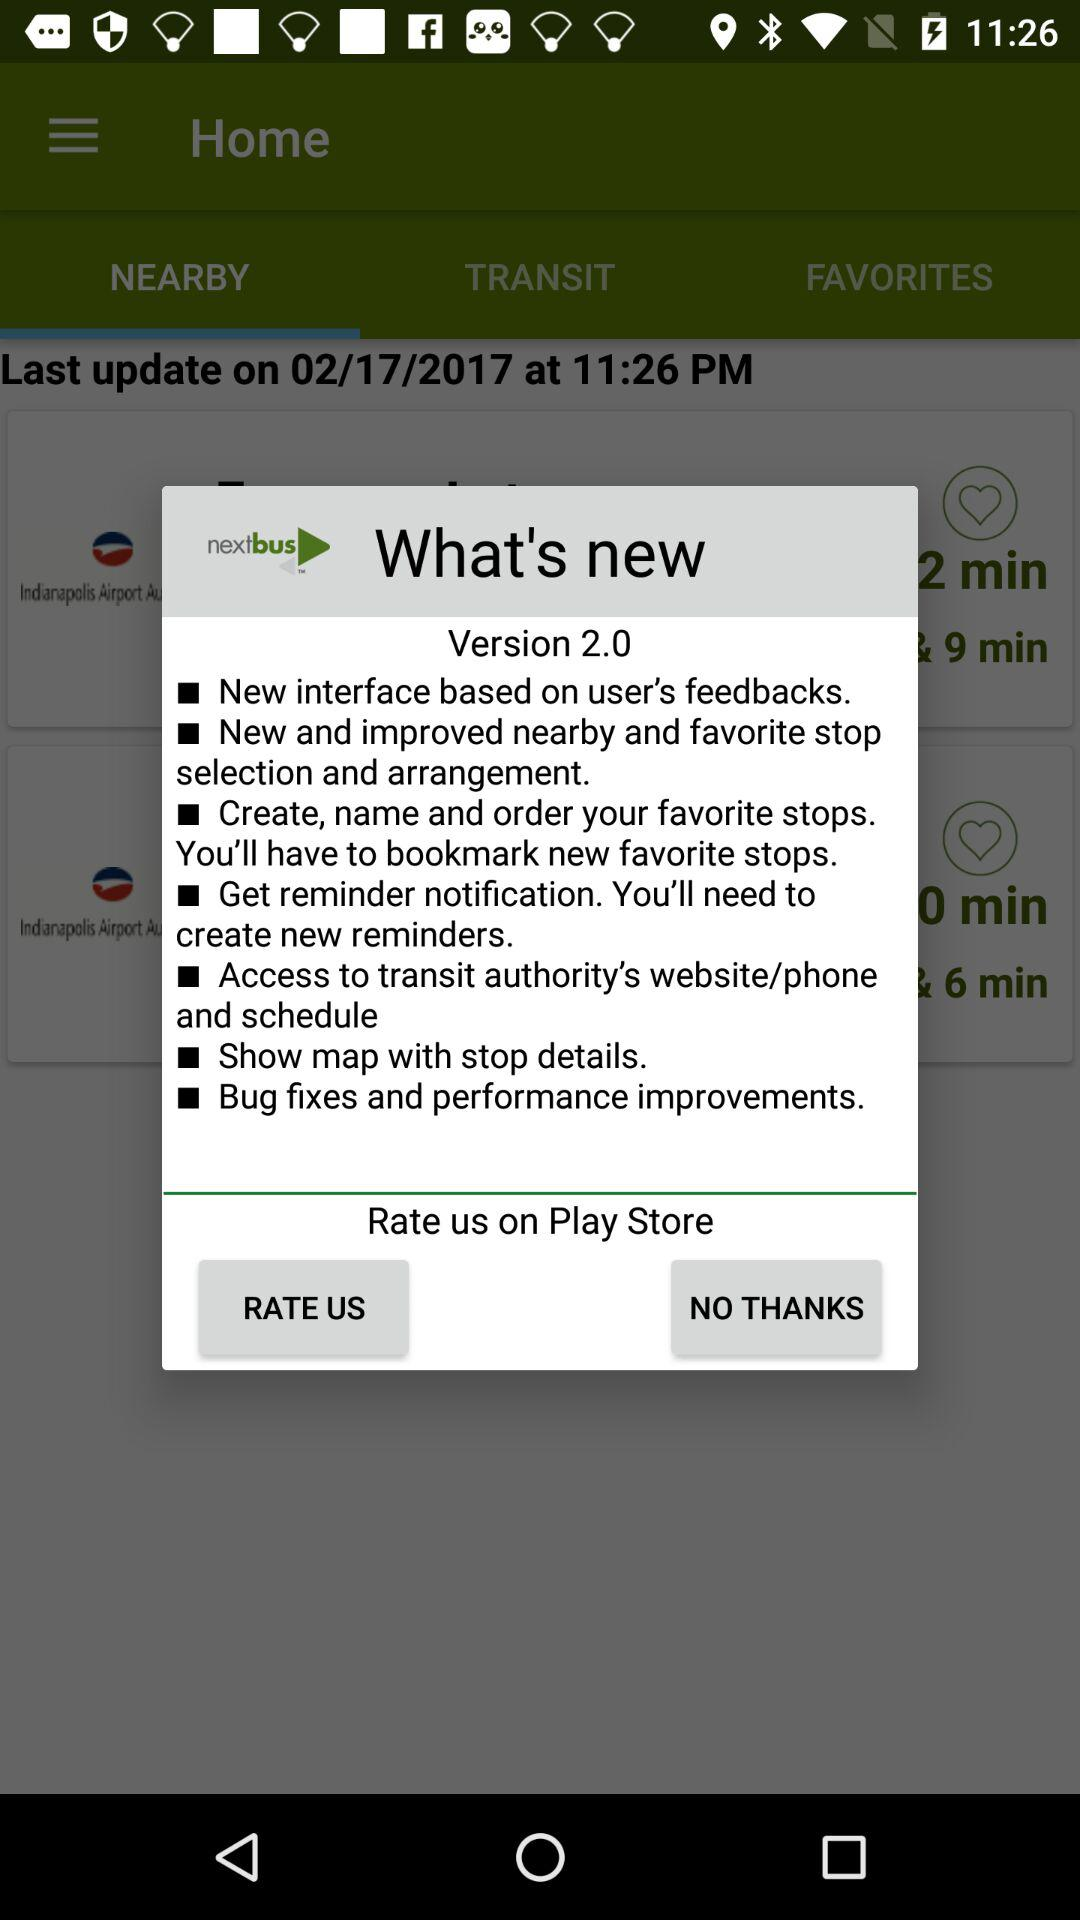What's new in version 2.0?
Answer the question using a single word or phrase. The new updates are "New interface based on user's feedbacks.", "New and improved nearby and favorite stop selection and arrangement.", "Create, name and order your favorite stops.You'll have to bookmark new favorite stops.", "Get reminder notification. You'll need to create new reminders.", "Access to transit authority's website/phone and schedule", "Show map with stop details." and "Bug fixes and performance improvements." 